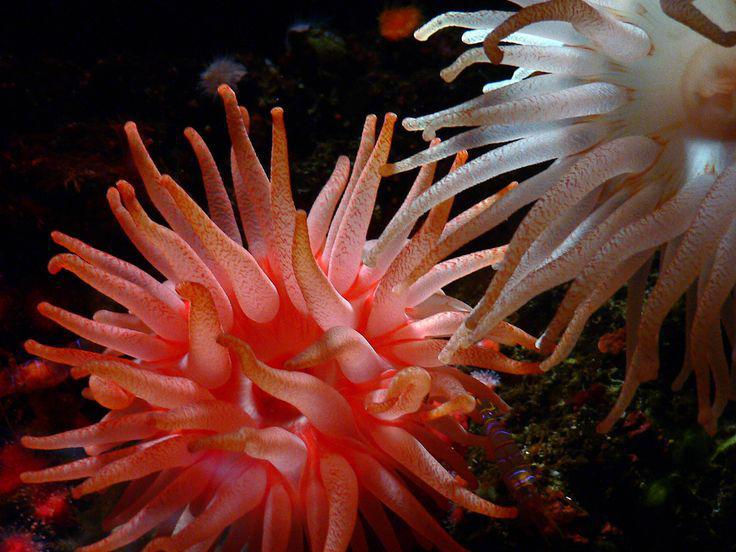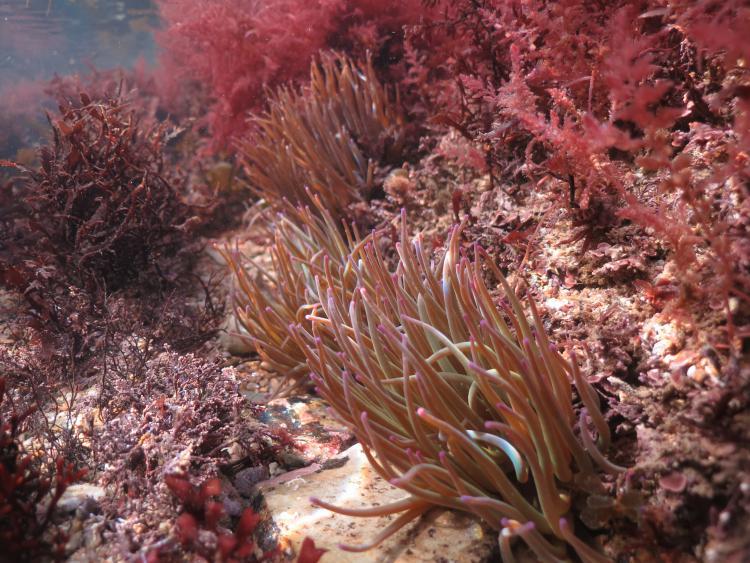The first image is the image on the left, the second image is the image on the right. Given the left and right images, does the statement "In at least one image there is a peach corral with no less than twenty tentacles being moved by the water." hold true? Answer yes or no. Yes. The first image is the image on the left, the second image is the image on the right. Examine the images to the left and right. Is the description "The left image includes at least eight yellowish anemone that resemble flowers." accurate? Answer yes or no. No. 